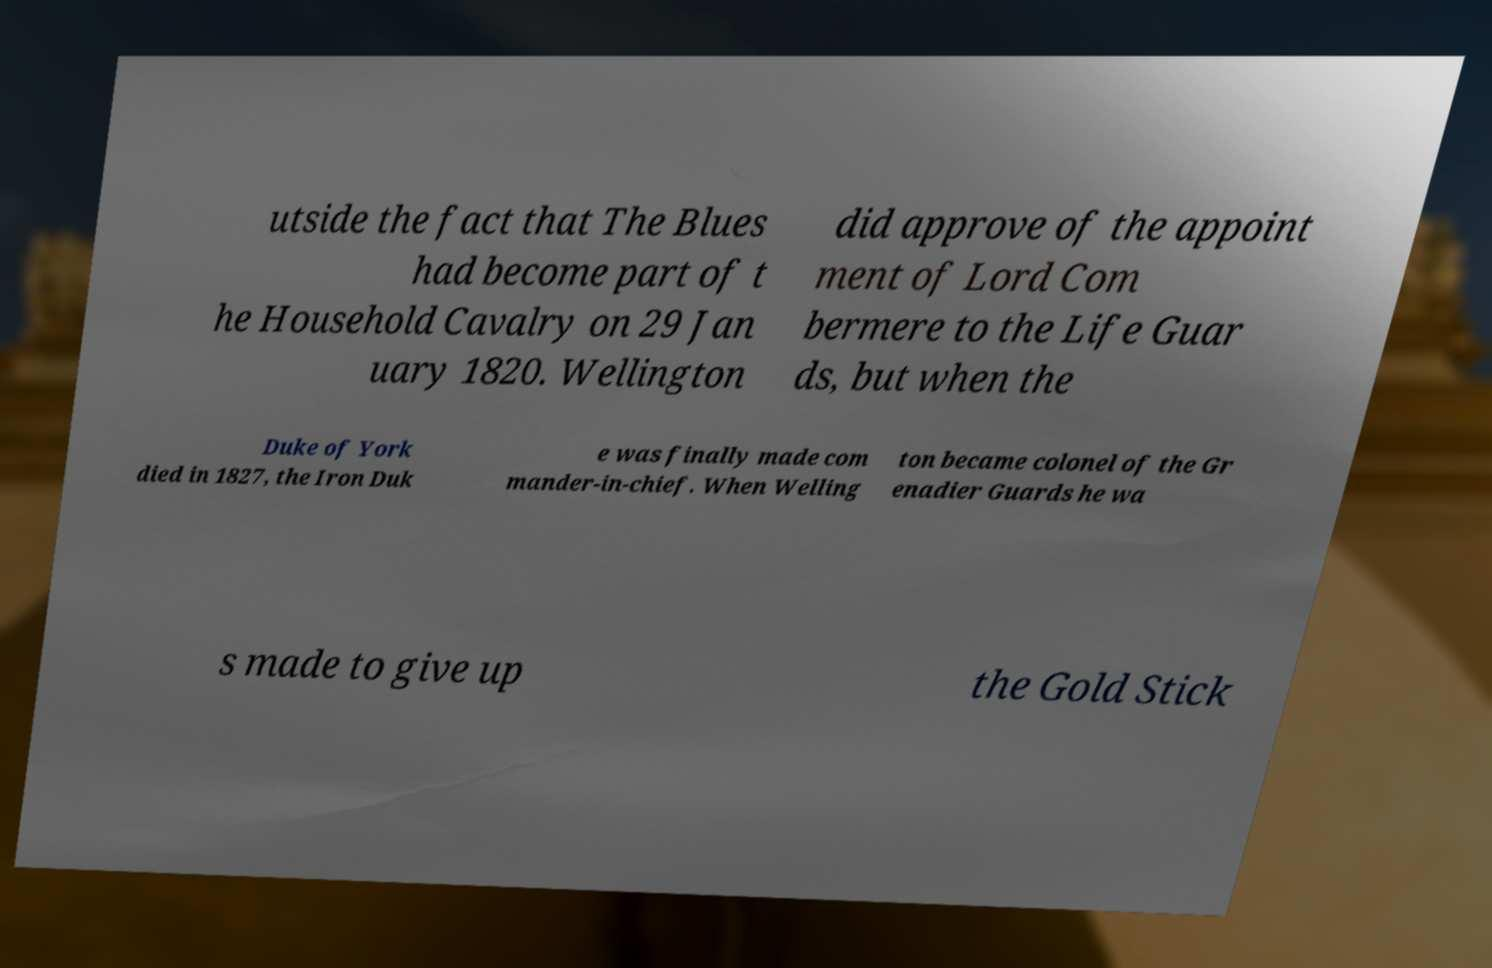Please identify and transcribe the text found in this image. utside the fact that The Blues had become part of t he Household Cavalry on 29 Jan uary 1820. Wellington did approve of the appoint ment of Lord Com bermere to the Life Guar ds, but when the Duke of York died in 1827, the Iron Duk e was finally made com mander-in-chief. When Welling ton became colonel of the Gr enadier Guards he wa s made to give up the Gold Stick 